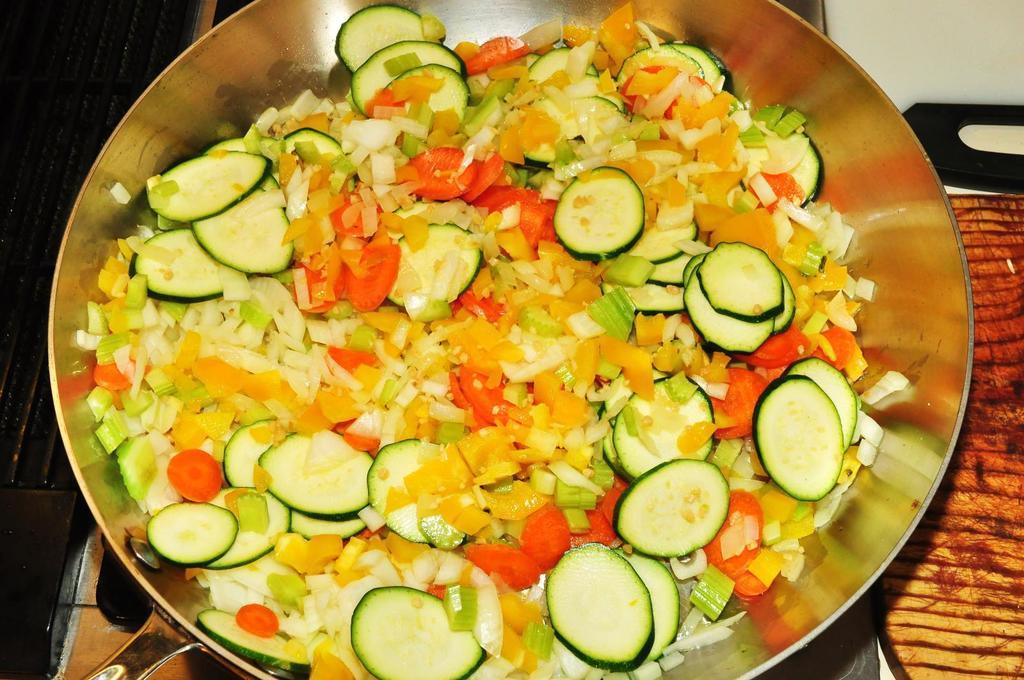In one or two sentences, can you explain what this image depicts? In this image there are vegetable slices in a bowl, and there is a chop board. 